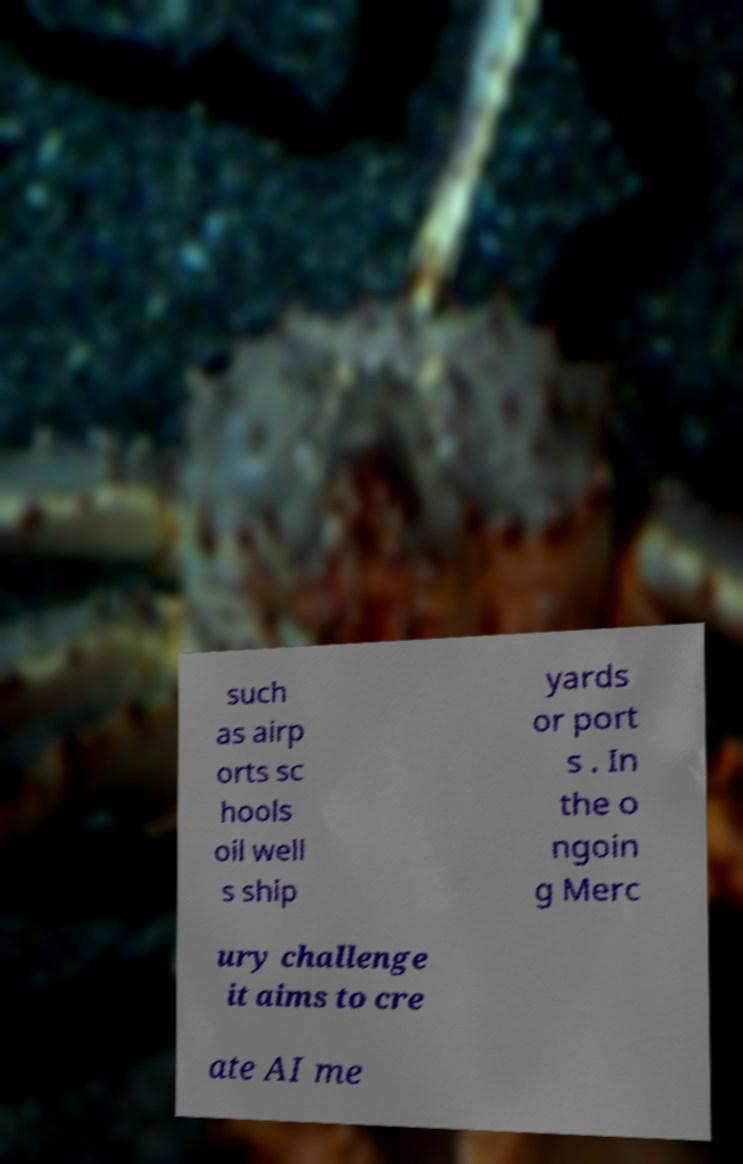There's text embedded in this image that I need extracted. Can you transcribe it verbatim? such as airp orts sc hools oil well s ship yards or port s . In the o ngoin g Merc ury challenge it aims to cre ate AI me 